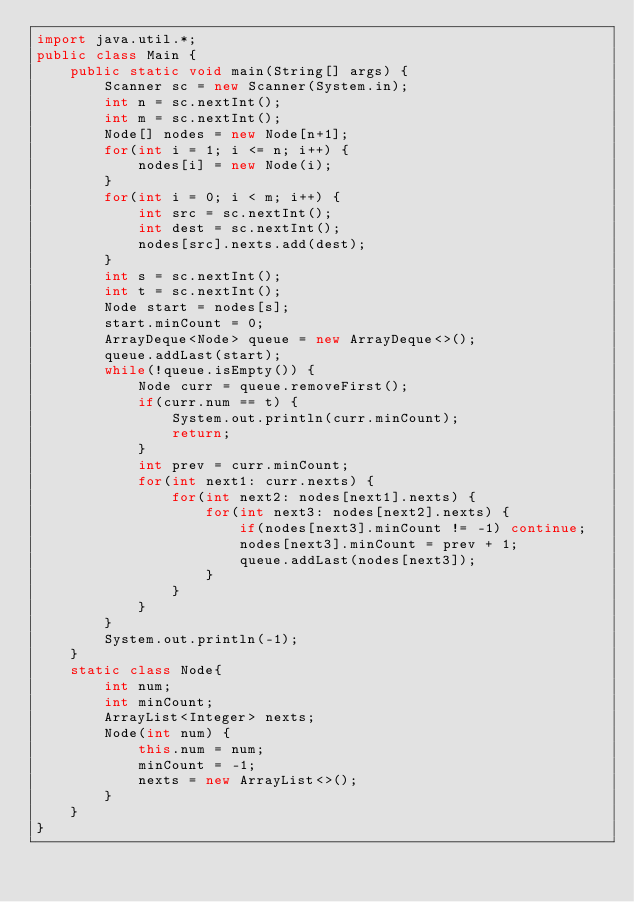Convert code to text. <code><loc_0><loc_0><loc_500><loc_500><_Java_>import java.util.*;
public class Main {
    public static void main(String[] args) {
        Scanner sc = new Scanner(System.in);
        int n = sc.nextInt();
        int m = sc.nextInt();
        Node[] nodes = new Node[n+1];
        for(int i = 1; i <= n; i++) {
            nodes[i] = new Node(i);
        }
        for(int i = 0; i < m; i++) {
            int src = sc.nextInt();
            int dest = sc.nextInt();
            nodes[src].nexts.add(dest);
        }
        int s = sc.nextInt();
        int t = sc.nextInt();
        Node start = nodes[s];
        start.minCount = 0;
        ArrayDeque<Node> queue = new ArrayDeque<>();
        queue.addLast(start);
        while(!queue.isEmpty()) {
            Node curr = queue.removeFirst();
            if(curr.num == t) {
                System.out.println(curr.minCount);
                return;
            }
            int prev = curr.minCount;
            for(int next1: curr.nexts) {
                for(int next2: nodes[next1].nexts) {
                    for(int next3: nodes[next2].nexts) {
                        if(nodes[next3].minCount != -1) continue;
                        nodes[next3].minCount = prev + 1;
                        queue.addLast(nodes[next3]);
                    }
                }
            }
        }
        System.out.println(-1);
    }
    static class Node{
        int num;
        int minCount;
        ArrayList<Integer> nexts;
        Node(int num) {
            this.num = num;
            minCount = -1;
            nexts = new ArrayList<>();
        }
    }
}
</code> 